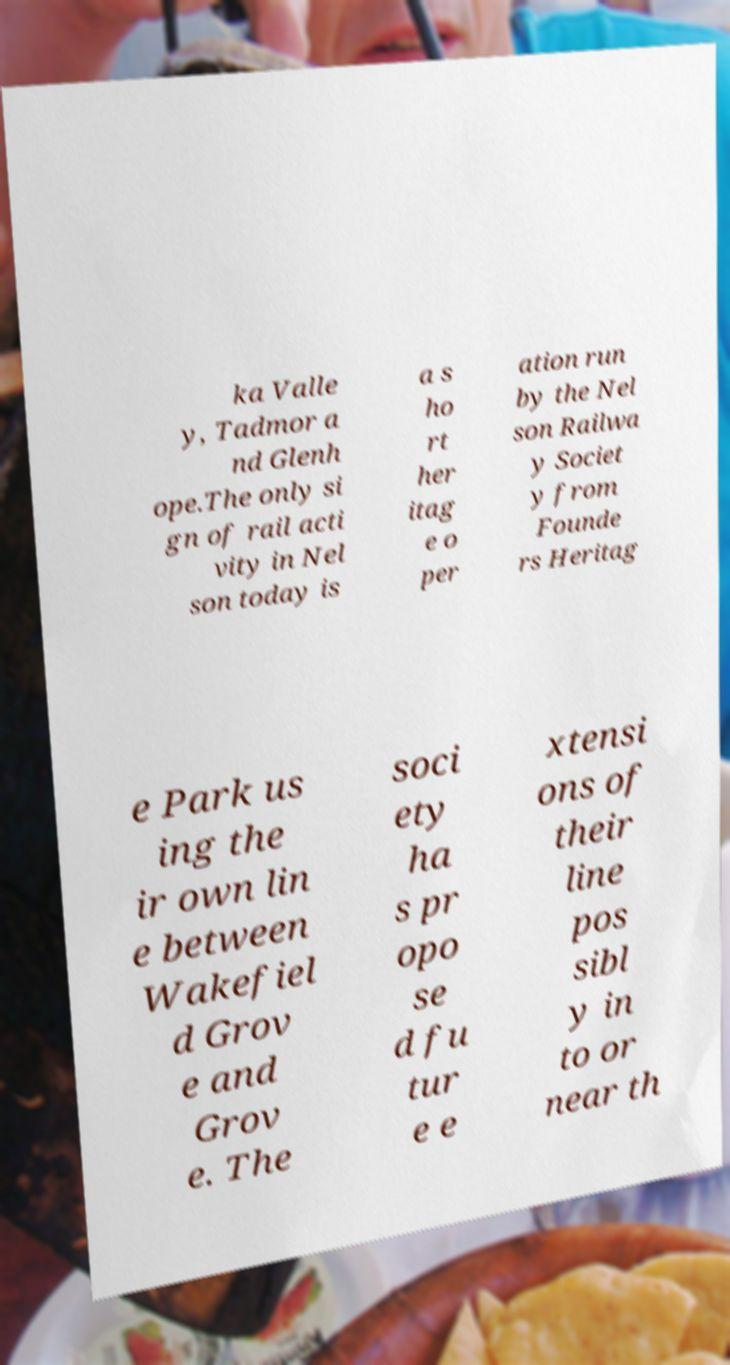There's text embedded in this image that I need extracted. Can you transcribe it verbatim? ka Valle y, Tadmor a nd Glenh ope.The only si gn of rail acti vity in Nel son today is a s ho rt her itag e o per ation run by the Nel son Railwa y Societ y from Founde rs Heritag e Park us ing the ir own lin e between Wakefiel d Grov e and Grov e. The soci ety ha s pr opo se d fu tur e e xtensi ons of their line pos sibl y in to or near th 